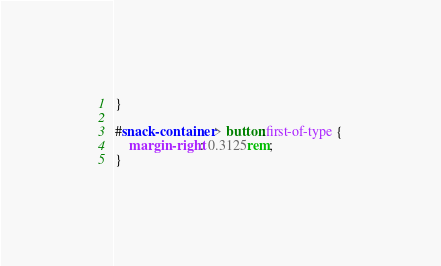Convert code to text. <code><loc_0><loc_0><loc_500><loc_500><_CSS_>}

#snack-container > button:first-of-type {
	margin-right: 0.3125rem;
}</code> 